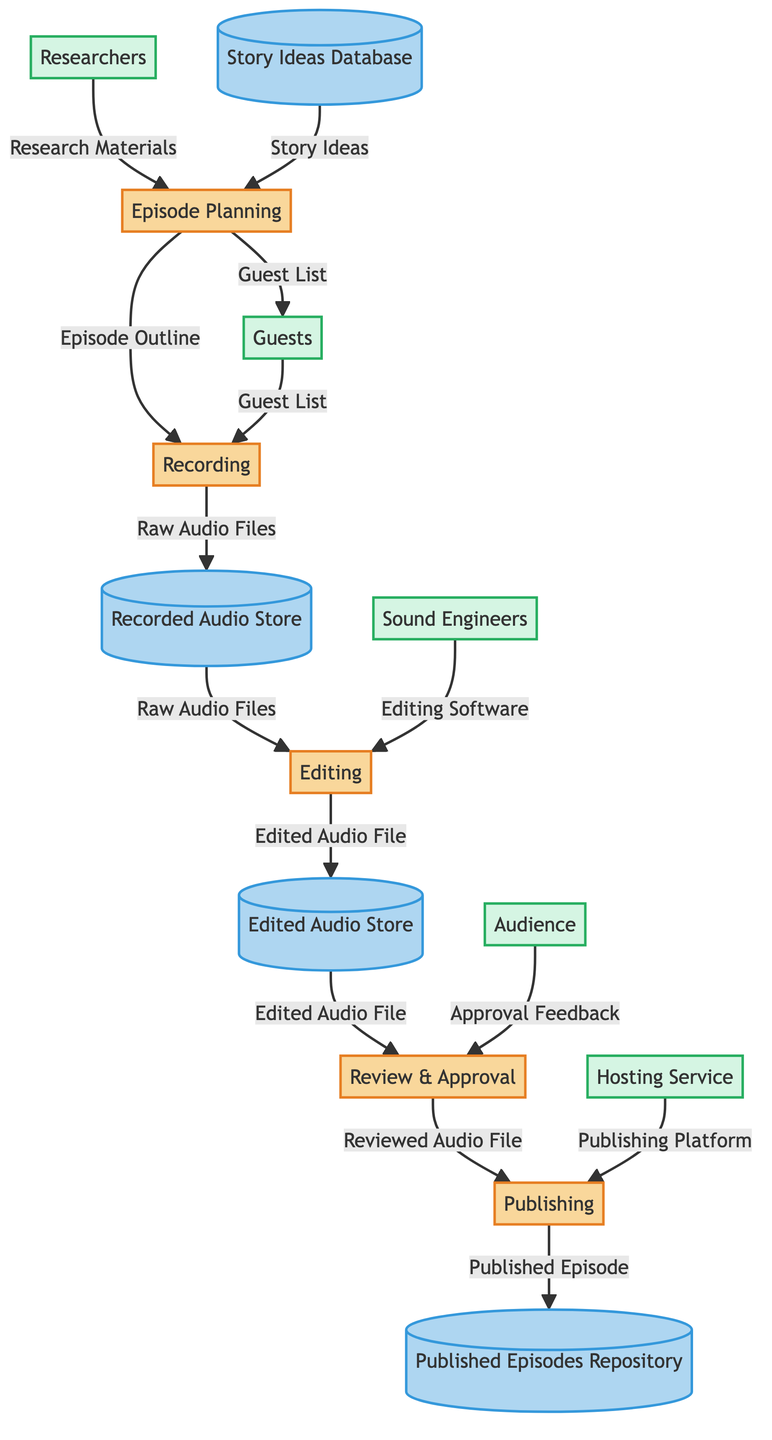What is the first process in the diagram? The first process in the diagram is labeled as "Episode Planning," which is positioned at the beginning of the flow.
Answer: Episode Planning How many external entities are present in the diagram? By counting the external entities displayed in the diagram, there are five entities listed: Researchers, Guests, Sound Engineers, Audience, and Hosting Service.
Answer: 5 Which process generates the 'Edited Audio File'? The 'Edited Audio File' is produced by the process labeled "Editing," which receives raw audio files and editing software as inputs.
Answer: Editing What data flows from the 'Review & Approval' process? The data flowing out of the 'Review & Approval' process includes two outputs: "Reviewed Audio File" and "Approval Feedback."
Answer: Reviewed Audio File, Approval Feedback Which data store contains 'Published Episode'? The data store that contains "Published Episode" is labeled as "Published Episodes Repository," which is the final data store in the flow after the publishing process.
Answer: Published Episodes Repository What is the input required for the 'Recording' process? The inputs required for the 'Recording' process include an "Episode Outline," "Recording Equipment," and "Guest List." These inputs are necessary to proceed with the recording of the episode.
Answer: Episode Outline, Recording Equipment, Guest List Which external entity interacts with 'Editing'? The external entity that interacts with the 'Editing' process is labeled "Sound Engineers," who provide the necessary editing software required for the editing process.
Answer: Sound Engineers What is the output of the 'Publishing' process? The output generated by the 'Publishing' process is labeled as "Published Episode," which indicates that the episode is made available to the audience once published.
Answer: Published Episode How many processes are listed in the diagram? The diagram lists a total of five processes: Episode Planning, Recording, Editing, Review & Approval, and Publishing.
Answer: 5 